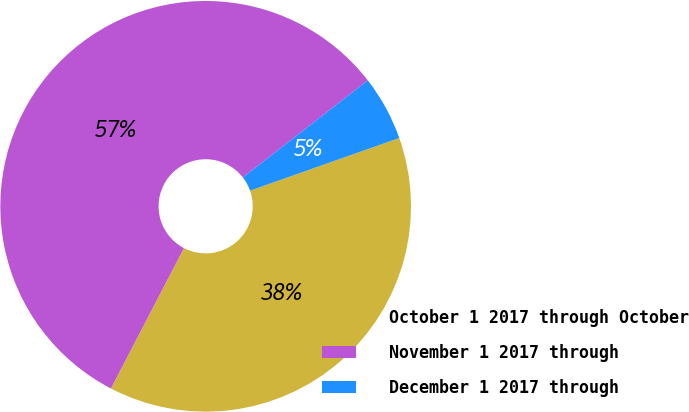Convert chart. <chart><loc_0><loc_0><loc_500><loc_500><pie_chart><fcel>October 1 2017 through October<fcel>November 1 2017 through<fcel>December 1 2017 through<nl><fcel>38.03%<fcel>56.86%<fcel>5.11%<nl></chart> 